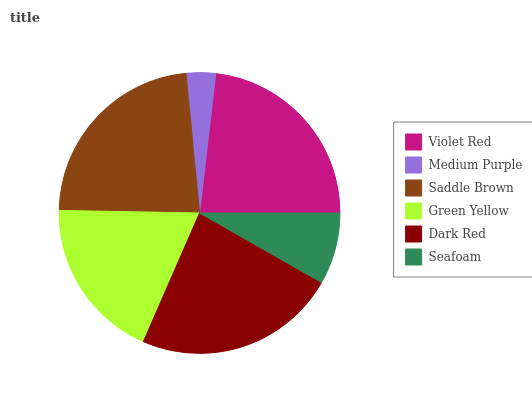Is Medium Purple the minimum?
Answer yes or no. Yes. Is Dark Red the maximum?
Answer yes or no. Yes. Is Saddle Brown the minimum?
Answer yes or no. No. Is Saddle Brown the maximum?
Answer yes or no. No. Is Saddle Brown greater than Medium Purple?
Answer yes or no. Yes. Is Medium Purple less than Saddle Brown?
Answer yes or no. Yes. Is Medium Purple greater than Saddle Brown?
Answer yes or no. No. Is Saddle Brown less than Medium Purple?
Answer yes or no. No. Is Violet Red the high median?
Answer yes or no. Yes. Is Green Yellow the low median?
Answer yes or no. Yes. Is Medium Purple the high median?
Answer yes or no. No. Is Medium Purple the low median?
Answer yes or no. No. 